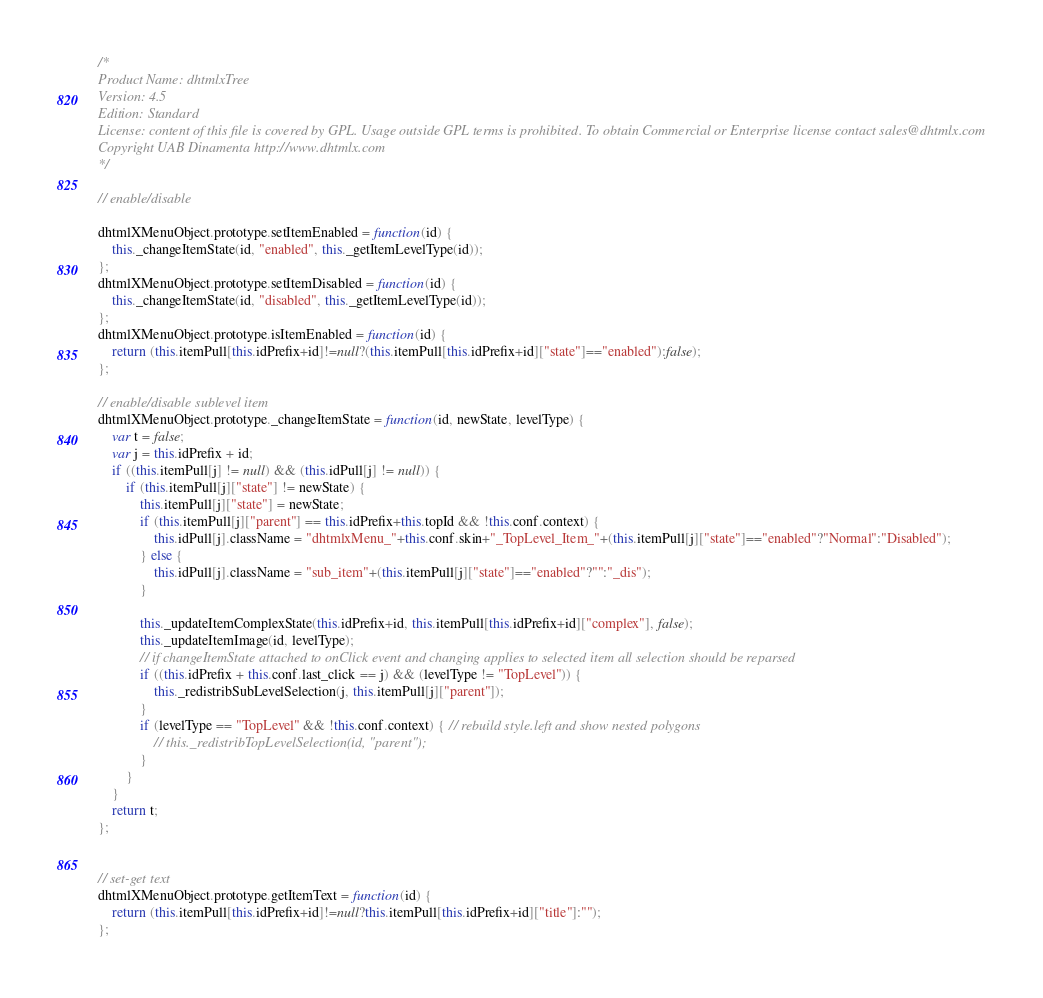Convert code to text. <code><loc_0><loc_0><loc_500><loc_500><_JavaScript_>/*
Product Name: dhtmlxTree 
Version: 4.5 
Edition: Standard 
License: content of this file is covered by GPL. Usage outside GPL terms is prohibited. To obtain Commercial or Enterprise license contact sales@dhtmlx.com
Copyright UAB Dinamenta http://www.dhtmlx.com
*/

// enable/disable

dhtmlXMenuObject.prototype.setItemEnabled = function(id) {
	this._changeItemState(id, "enabled", this._getItemLevelType(id));
};
dhtmlXMenuObject.prototype.setItemDisabled = function(id) {
	this._changeItemState(id, "disabled", this._getItemLevelType(id));
};
dhtmlXMenuObject.prototype.isItemEnabled = function(id) {
	return (this.itemPull[this.idPrefix+id]!=null?(this.itemPull[this.idPrefix+id]["state"]=="enabled"):false);
};

// enable/disable sublevel item
dhtmlXMenuObject.prototype._changeItemState = function(id, newState, levelType) {
	var t = false;
	var j = this.idPrefix + id;
	if ((this.itemPull[j] != null) && (this.idPull[j] != null)) {
		if (this.itemPull[j]["state"] != newState) {
			this.itemPull[j]["state"] = newState;
			if (this.itemPull[j]["parent"] == this.idPrefix+this.topId && !this.conf.context) {
				this.idPull[j].className = "dhtmlxMenu_"+this.conf.skin+"_TopLevel_Item_"+(this.itemPull[j]["state"]=="enabled"?"Normal":"Disabled");
			} else {
				this.idPull[j].className = "sub_item"+(this.itemPull[j]["state"]=="enabled"?"":"_dis");
			}
			
			this._updateItemComplexState(this.idPrefix+id, this.itemPull[this.idPrefix+id]["complex"], false);
			this._updateItemImage(id, levelType);
			// if changeItemState attached to onClick event and changing applies to selected item all selection should be reparsed
			if ((this.idPrefix + this.conf.last_click == j) && (levelType != "TopLevel")) {
				this._redistribSubLevelSelection(j, this.itemPull[j]["parent"]);
			}
			if (levelType == "TopLevel" && !this.conf.context) { // rebuild style.left and show nested polygons
				// this._redistribTopLevelSelection(id, "parent");
			}
		}
	}
	return t;
};


// set-get text
dhtmlXMenuObject.prototype.getItemText = function(id) {
	return (this.itemPull[this.idPrefix+id]!=null?this.itemPull[this.idPrefix+id]["title"]:"");
};
</code> 